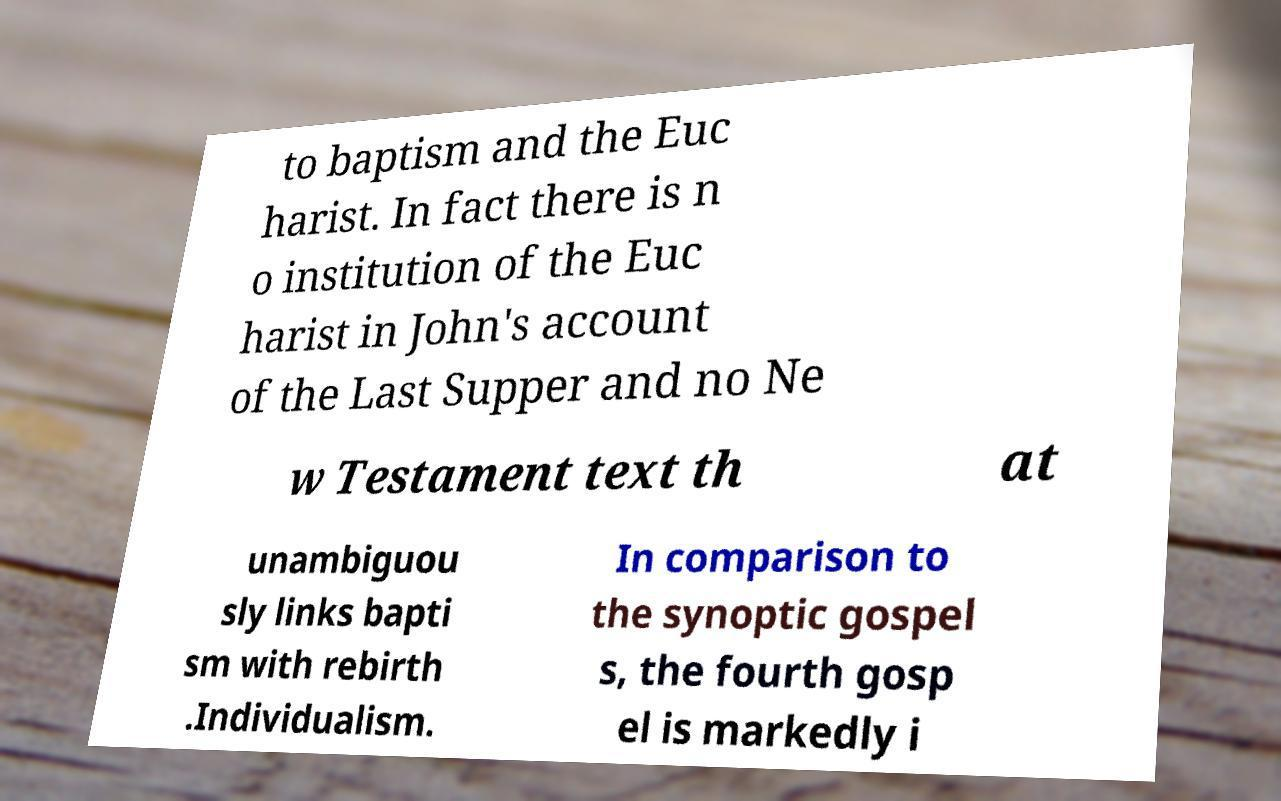Could you extract and type out the text from this image? to baptism and the Euc harist. In fact there is n o institution of the Euc harist in John's account of the Last Supper and no Ne w Testament text th at unambiguou sly links bapti sm with rebirth .Individualism. In comparison to the synoptic gospel s, the fourth gosp el is markedly i 